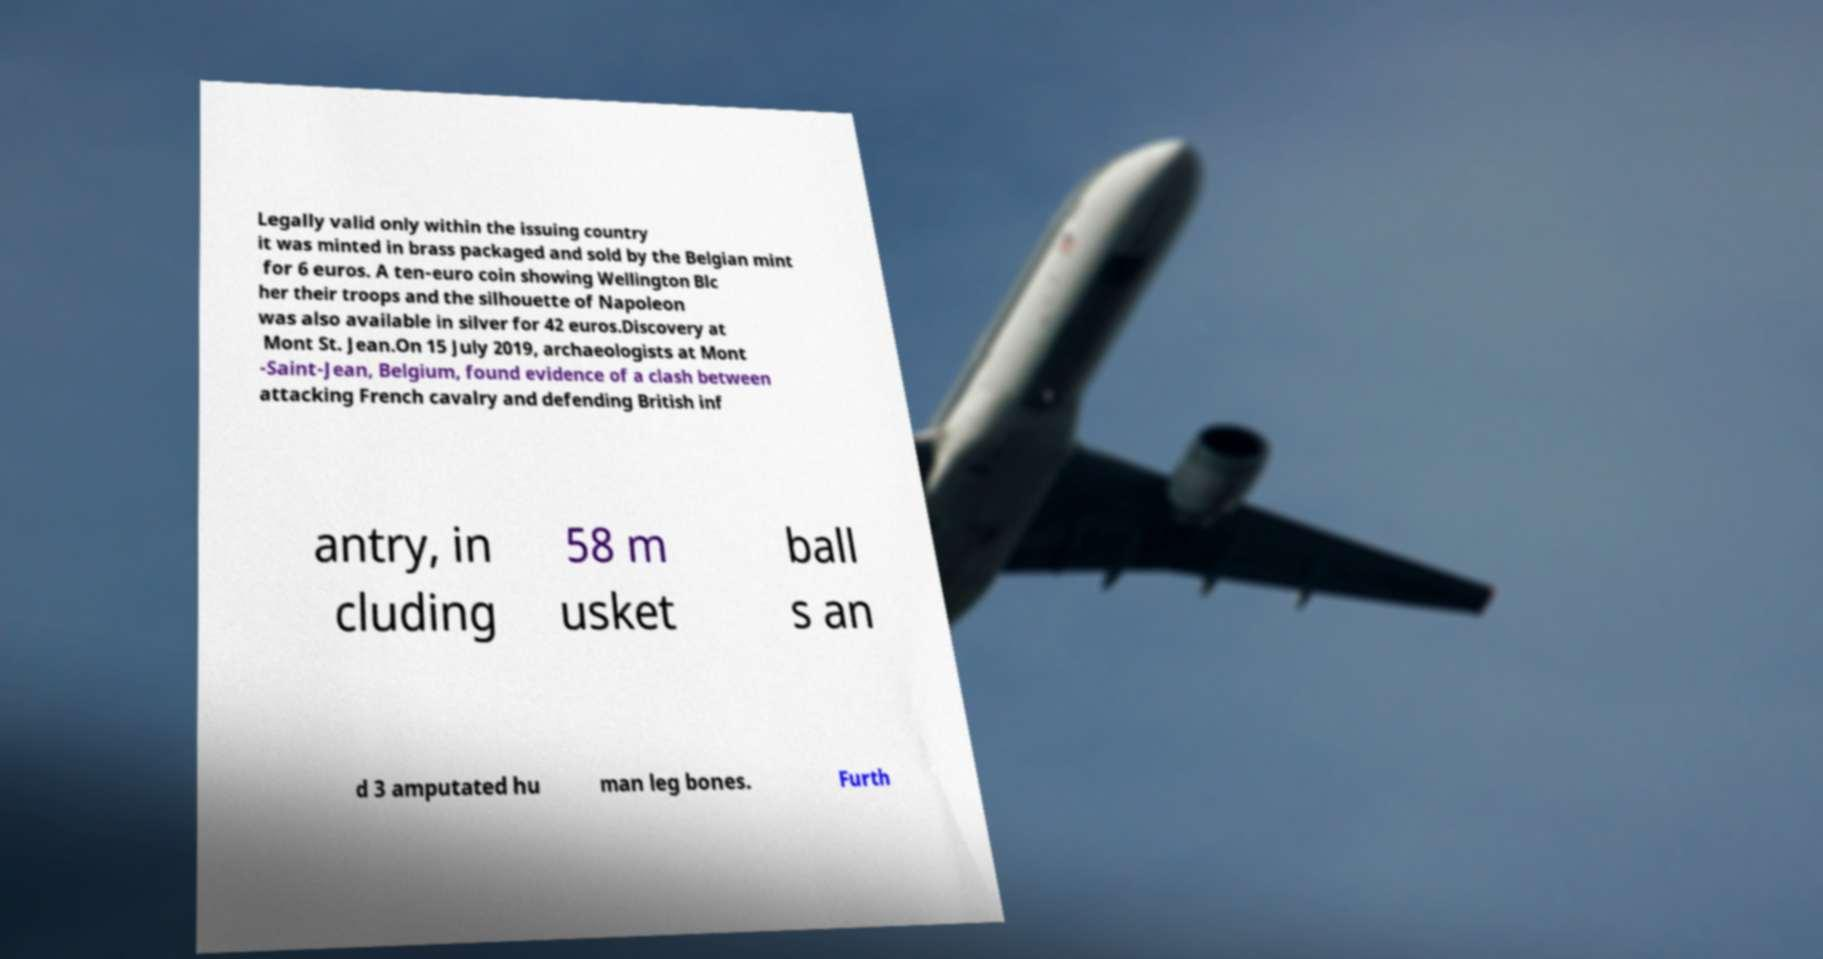Please read and relay the text visible in this image. What does it say? Legally valid only within the issuing country it was minted in brass packaged and sold by the Belgian mint for 6 euros. A ten-euro coin showing Wellington Blc her their troops and the silhouette of Napoleon was also available in silver for 42 euros.Discovery at Mont St. Jean.On 15 July 2019, archaeologists at Mont -Saint-Jean, Belgium, found evidence of a clash between attacking French cavalry and defending British inf antry, in cluding 58 m usket ball s an d 3 amputated hu man leg bones. Furth 